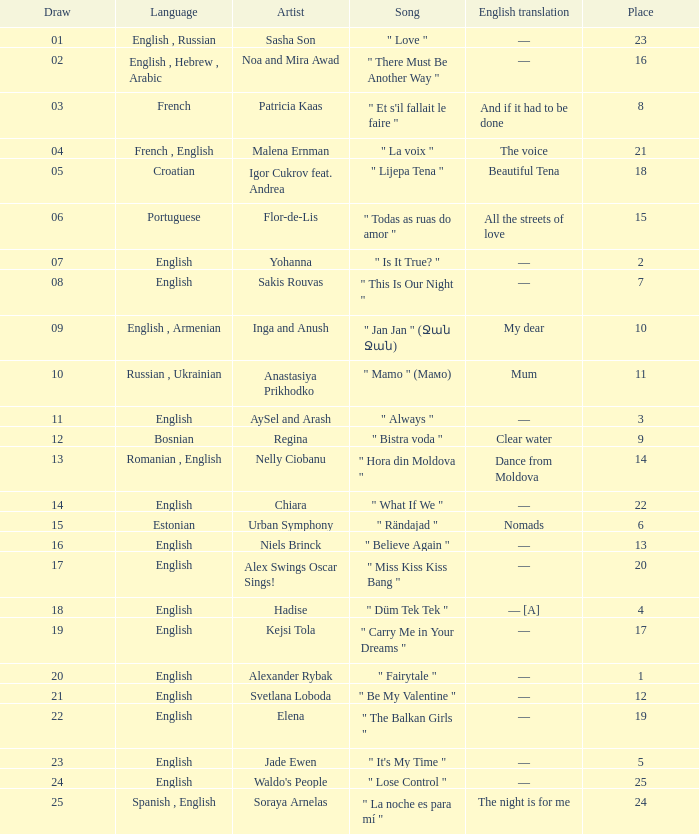What was the english interpretation for the song by svetlana loboda? —. Could you help me parse every detail presented in this table? {'header': ['Draw', 'Language', 'Artist', 'Song', 'English translation', 'Place'], 'rows': [['01', 'English , Russian', 'Sasha Son', '" Love "', '—', '23'], ['02', 'English , Hebrew , Arabic', 'Noa and Mira Awad', '" There Must Be Another Way "', '—', '16'], ['03', 'French', 'Patricia Kaas', '" Et s\'il fallait le faire "', 'And if it had to be done', '8'], ['04', 'French , English', 'Malena Ernman', '" La voix "', 'The voice', '21'], ['05', 'Croatian', 'Igor Cukrov feat. Andrea', '" Lijepa Tena "', 'Beautiful Tena', '18'], ['06', 'Portuguese', 'Flor-de-Lis', '" Todas as ruas do amor "', 'All the streets of love', '15'], ['07', 'English', 'Yohanna', '" Is It True? "', '—', '2'], ['08', 'English', 'Sakis Rouvas', '" This Is Our Night "', '—', '7'], ['09', 'English , Armenian', 'Inga and Anush', '" Jan Jan " (Ջան Ջան)', 'My dear', '10'], ['10', 'Russian , Ukrainian', 'Anastasiya Prikhodko', '" Mamo " (Мамо)', 'Mum', '11'], ['11', 'English', 'AySel and Arash', '" Always "', '—', '3'], ['12', 'Bosnian', 'Regina', '" Bistra voda "', 'Clear water', '9'], ['13', 'Romanian , English', 'Nelly Ciobanu', '" Hora din Moldova "', 'Dance from Moldova', '14'], ['14', 'English', 'Chiara', '" What If We "', '—', '22'], ['15', 'Estonian', 'Urban Symphony', '" Rändajad "', 'Nomads', '6'], ['16', 'English', 'Niels Brinck', '" Believe Again "', '—', '13'], ['17', 'English', 'Alex Swings Oscar Sings!', '" Miss Kiss Kiss Bang "', '—', '20'], ['18', 'English', 'Hadise', '" Düm Tek Tek "', '— [A]', '4'], ['19', 'English', 'Kejsi Tola', '" Carry Me in Your Dreams "', '—', '17'], ['20', 'English', 'Alexander Rybak', '" Fairytale "', '—', '1'], ['21', 'English', 'Svetlana Loboda', '" Be My Valentine "', '—', '12'], ['22', 'English', 'Elena', '" The Balkan Girls "', '—', '19'], ['23', 'English', 'Jade Ewen', '" It\'s My Time "', '—', '5'], ['24', 'English', "Waldo's People", '" Lose Control "', '—', '25'], ['25', 'Spanish , English', 'Soraya Arnelas', '" La noche es para mí "', 'The night is for me', '24']]} 